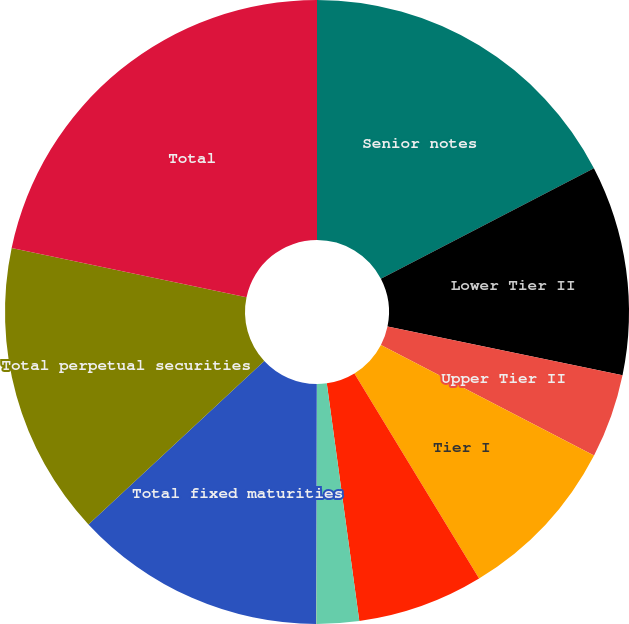<chart> <loc_0><loc_0><loc_500><loc_500><pie_chart><fcel>Senior notes<fcel>Lower Tier II<fcel>Upper Tier II<fcel>Tier I<fcel>Surplus Notes<fcel>Trust Preferred - Non-banks<fcel>Other Subordinated - Non-banks<fcel>Total fixed maturities<fcel>Total perpetual securities<fcel>Total<nl><fcel>17.38%<fcel>10.87%<fcel>4.36%<fcel>8.7%<fcel>6.53%<fcel>2.19%<fcel>0.02%<fcel>13.04%<fcel>15.21%<fcel>21.71%<nl></chart> 